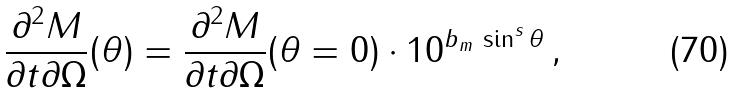Convert formula to latex. <formula><loc_0><loc_0><loc_500><loc_500>\frac { \partial ^ { 2 } M } { \partial t \partial \Omega } ( \theta ) = \frac { \partial ^ { 2 } M } { \partial t \partial \Omega } ( \theta = 0 ) \cdot 1 0 ^ { b _ { m } \, \sin ^ { s } \theta } \, ,</formula> 